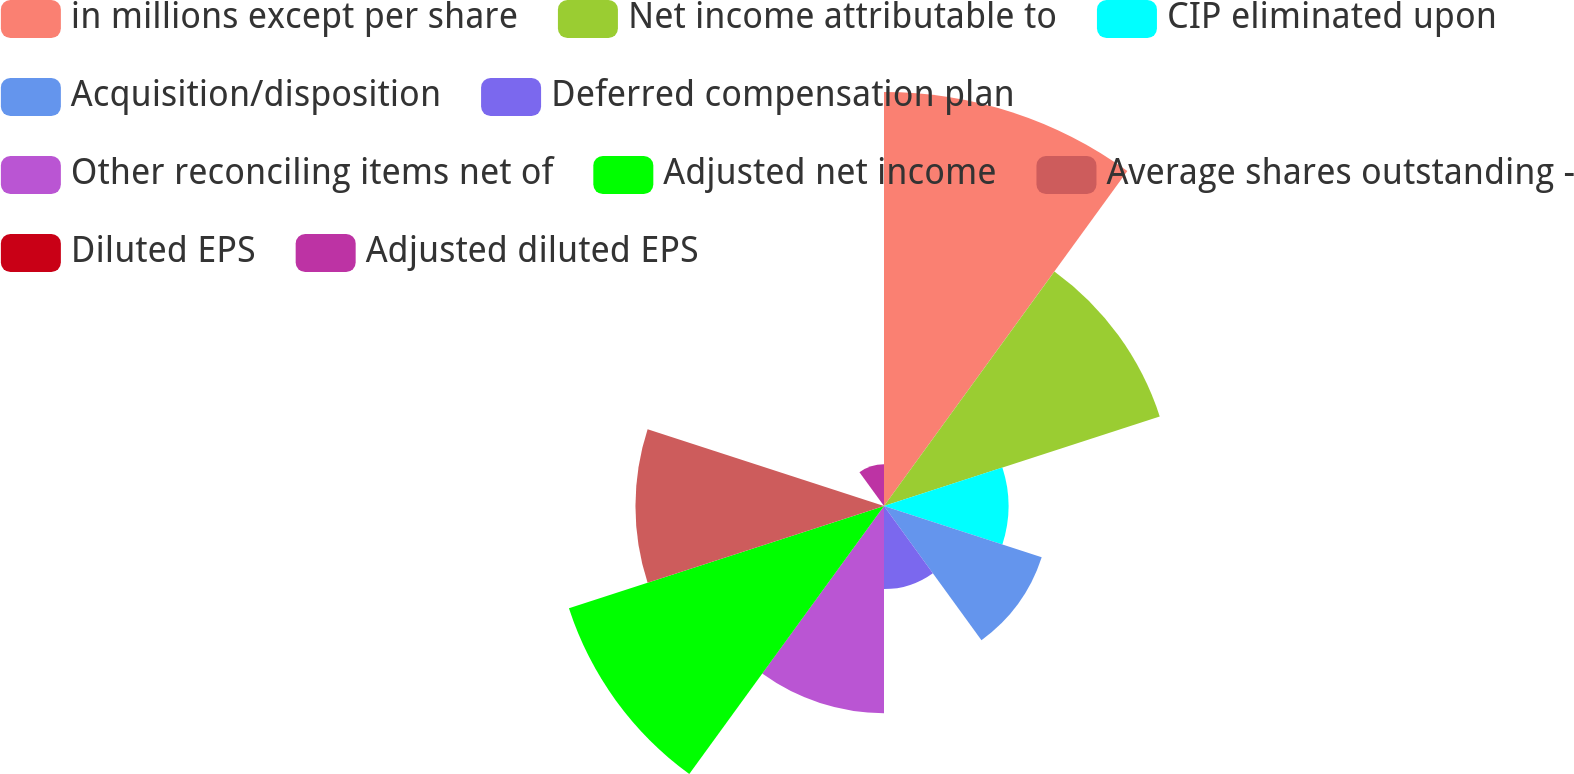Convert chart. <chart><loc_0><loc_0><loc_500><loc_500><pie_chart><fcel>in millions except per share<fcel>Net income attributable to<fcel>CIP eliminated upon<fcel>Acquisition/disposition<fcel>Deferred compensation plan<fcel>Other reconciling items net of<fcel>Adjusted net income<fcel>Average shares outstanding -<fcel>Diluted EPS<fcel>Adjusted diluted EPS<nl><fcel>21.72%<fcel>15.21%<fcel>6.53%<fcel>8.7%<fcel>4.36%<fcel>10.87%<fcel>17.38%<fcel>13.04%<fcel>0.02%<fcel>2.19%<nl></chart> 